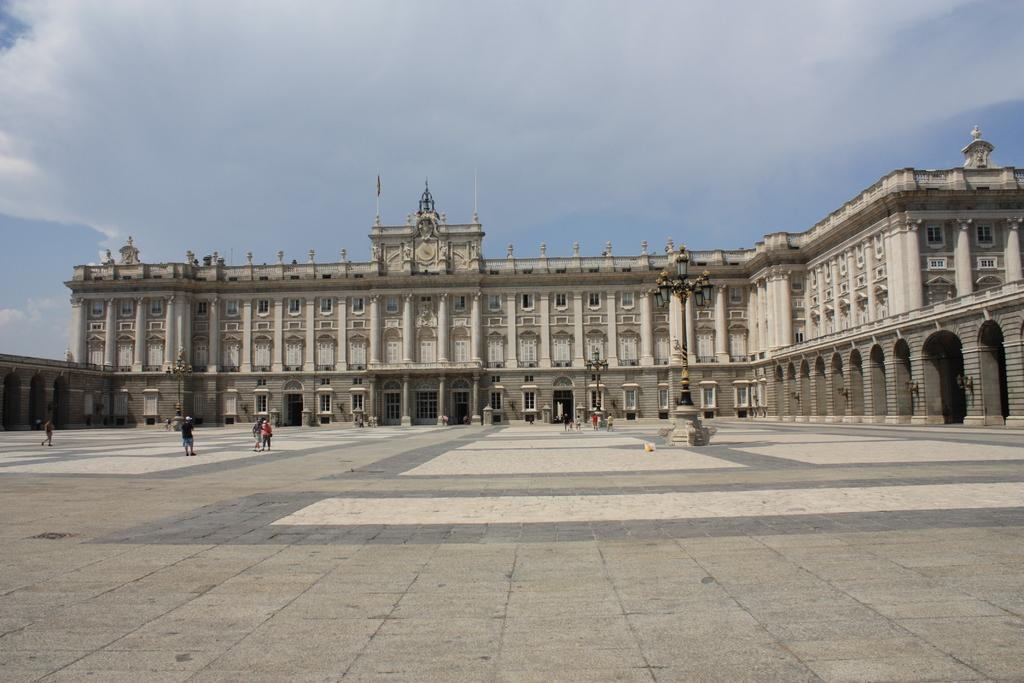Who or what can be seen in the image? There are people in the image. What type of structure is visible in the background? There is a building with pillars, windows, and arches in the background. What is the flag attached to in the background? The flag is attached to a pole in the background. What can be seen in the sky in the background? The sky with clouds is visible in the background. How many oranges are hanging from the arches of the building in the image? There are no oranges present in the image; the building has arches, but no oranges are hanging from them. 